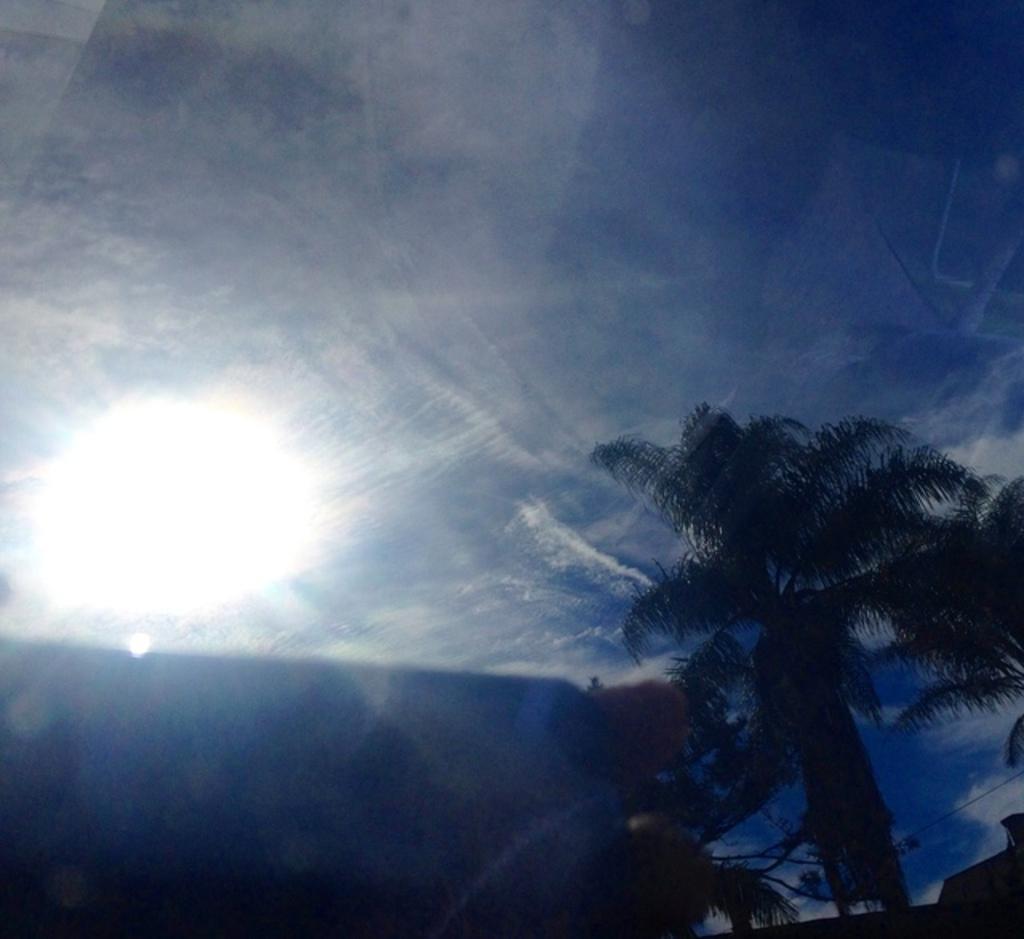How would you summarize this image in a sentence or two? There are trees at the bottom of this image, and there is a sky in the background. It seems like a sunlight as we can see on the left side of this image. 